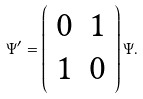Convert formula to latex. <formula><loc_0><loc_0><loc_500><loc_500>\Psi ^ { \prime } = \left ( \begin{array} { c c } 0 & 1 \\ 1 & 0 \end{array} \right ) \Psi .</formula> 